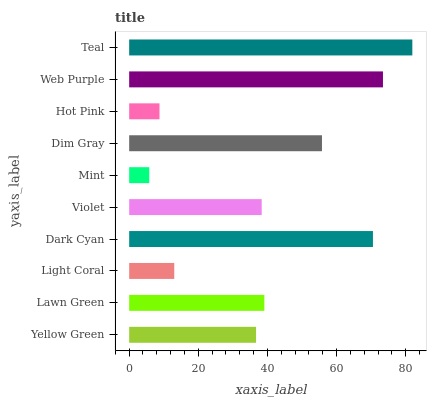Is Mint the minimum?
Answer yes or no. Yes. Is Teal the maximum?
Answer yes or no. Yes. Is Lawn Green the minimum?
Answer yes or no. No. Is Lawn Green the maximum?
Answer yes or no. No. Is Lawn Green greater than Yellow Green?
Answer yes or no. Yes. Is Yellow Green less than Lawn Green?
Answer yes or no. Yes. Is Yellow Green greater than Lawn Green?
Answer yes or no. No. Is Lawn Green less than Yellow Green?
Answer yes or no. No. Is Lawn Green the high median?
Answer yes or no. Yes. Is Violet the low median?
Answer yes or no. Yes. Is Hot Pink the high median?
Answer yes or no. No. Is Mint the low median?
Answer yes or no. No. 